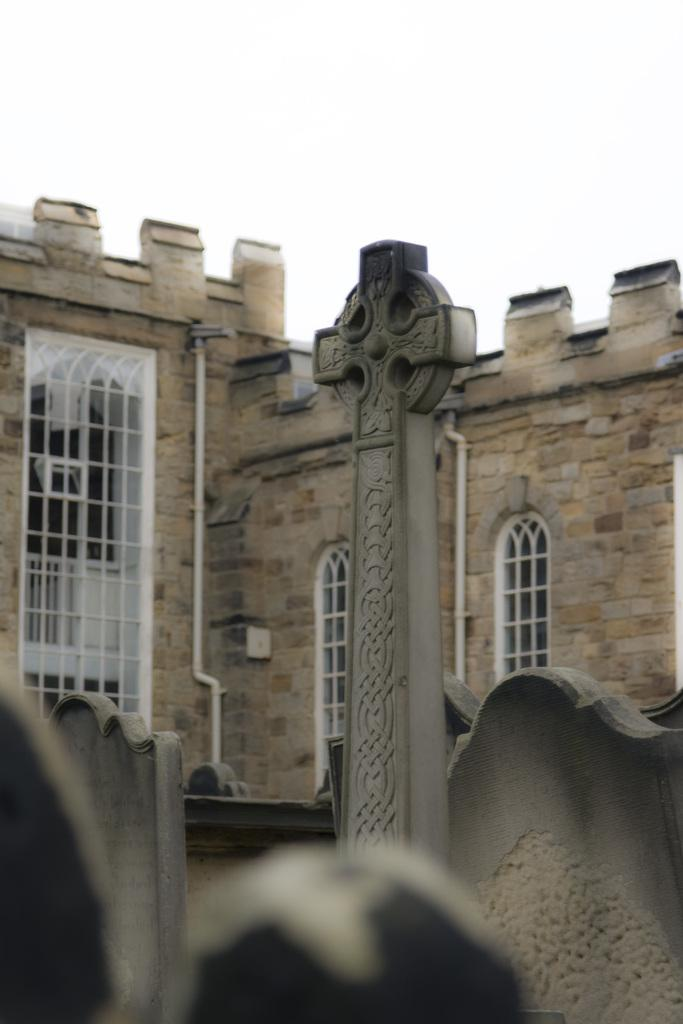What type of structure is present in the image? There is a building in the image. What can be seen in the background of the image? The sky is visible in the background of the image. What color is the daughter's bath in the image? There is no daughter or bath present in the image. 